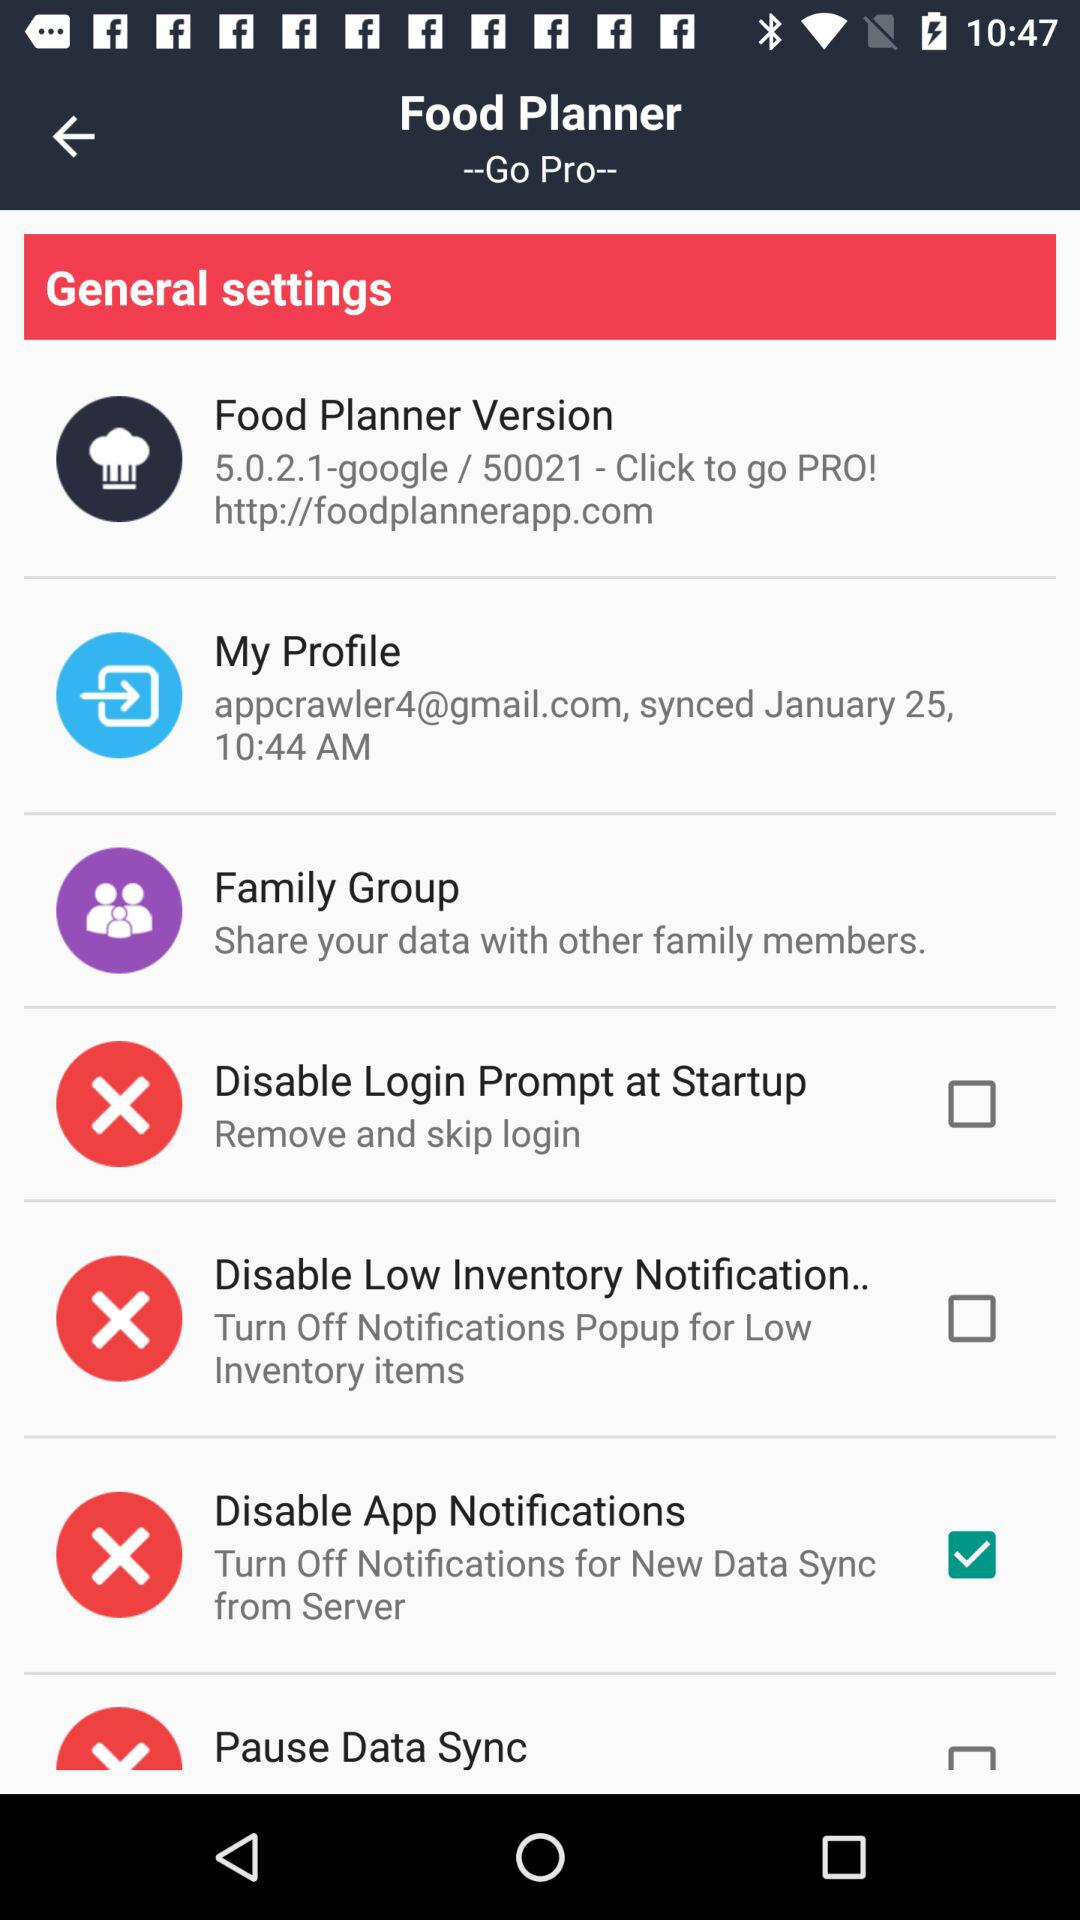What is the email address of the user? The email address of the user is appcrawler4@gmail.com. 